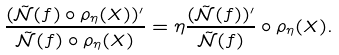Convert formula to latex. <formula><loc_0><loc_0><loc_500><loc_500>\frac { ( \tilde { \mathcal { N } } ( f ) \circ \rho _ { \eta } ( X ) ) ^ { \prime } } { \tilde { \mathcal { N } } ( f ) \circ \rho _ { \eta } ( X ) } = \eta \frac { ( \tilde { \mathcal { N } } ( f ) ) ^ { \prime } } { \tilde { \mathcal { N } } ( f ) } \circ \rho _ { \eta } ( X ) .</formula> 